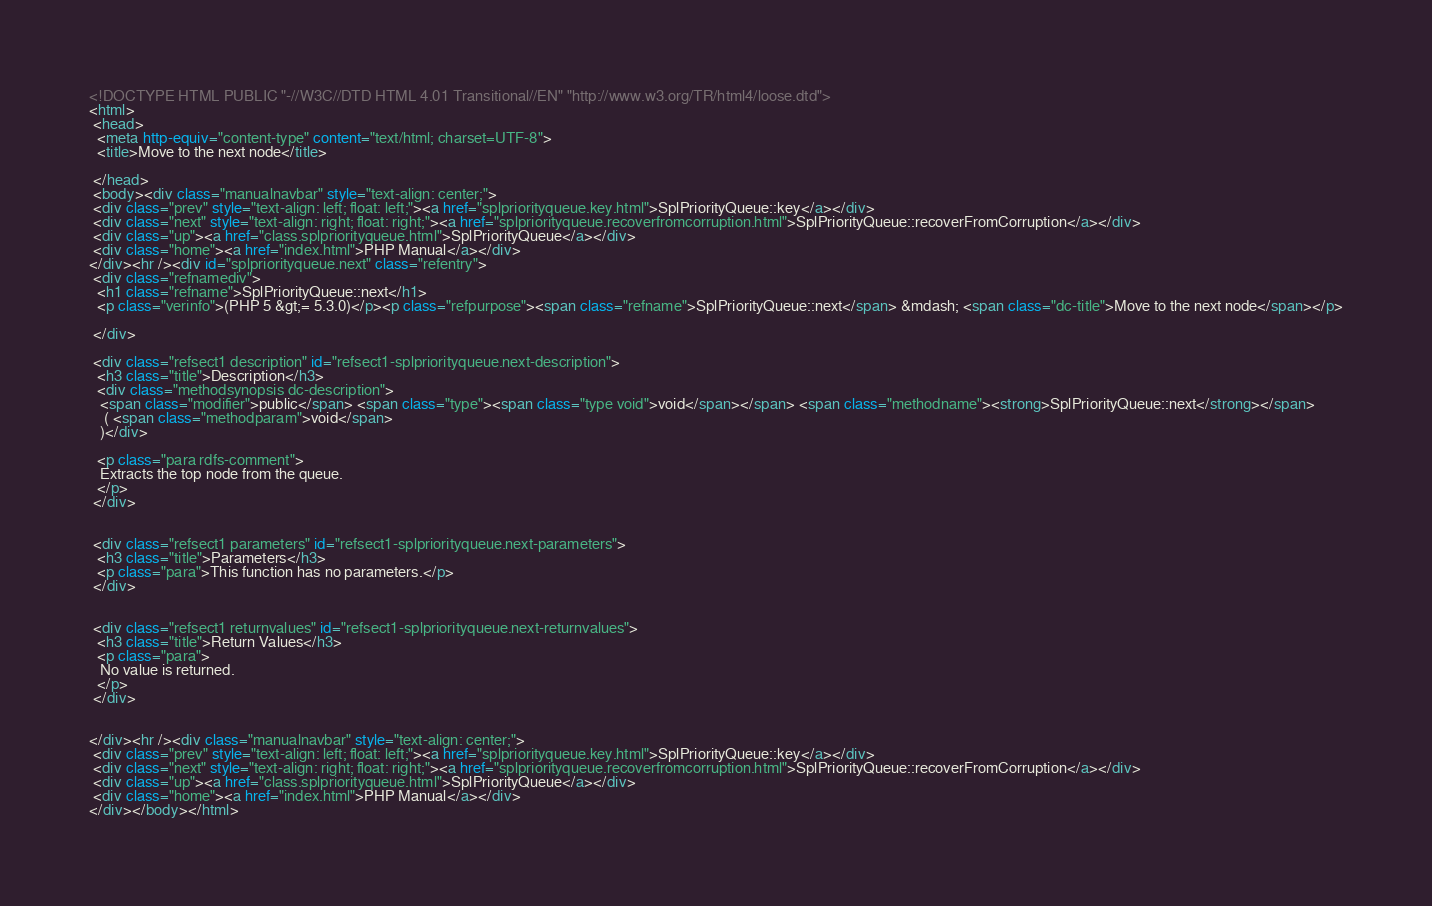<code> <loc_0><loc_0><loc_500><loc_500><_HTML_><!DOCTYPE HTML PUBLIC "-//W3C//DTD HTML 4.01 Transitional//EN" "http://www.w3.org/TR/html4/loose.dtd">
<html>
 <head>
  <meta http-equiv="content-type" content="text/html; charset=UTF-8">
  <title>Move to the next node</title>

 </head>
 <body><div class="manualnavbar" style="text-align: center;">
 <div class="prev" style="text-align: left; float: left;"><a href="splpriorityqueue.key.html">SplPriorityQueue::key</a></div>
 <div class="next" style="text-align: right; float: right;"><a href="splpriorityqueue.recoverfromcorruption.html">SplPriorityQueue::recoverFromCorruption</a></div>
 <div class="up"><a href="class.splpriorityqueue.html">SplPriorityQueue</a></div>
 <div class="home"><a href="index.html">PHP Manual</a></div>
</div><hr /><div id="splpriorityqueue.next" class="refentry">
 <div class="refnamediv">
  <h1 class="refname">SplPriorityQueue::next</h1>
  <p class="verinfo">(PHP 5 &gt;= 5.3.0)</p><p class="refpurpose"><span class="refname">SplPriorityQueue::next</span> &mdash; <span class="dc-title">Move to the next node</span></p>

 </div>

 <div class="refsect1 description" id="refsect1-splpriorityqueue.next-description">
  <h3 class="title">Description</h3>
  <div class="methodsynopsis dc-description">
   <span class="modifier">public</span> <span class="type"><span class="type void">void</span></span> <span class="methodname"><strong>SplPriorityQueue::next</strong></span>
    ( <span class="methodparam">void</span>
   )</div>

  <p class="para rdfs-comment">
   Extracts the top node from the queue.
  </p>
 </div>


 <div class="refsect1 parameters" id="refsect1-splpriorityqueue.next-parameters">
  <h3 class="title">Parameters</h3>
  <p class="para">This function has no parameters.</p>
 </div>


 <div class="refsect1 returnvalues" id="refsect1-splpriorityqueue.next-returnvalues">
  <h3 class="title">Return Values</h3>
  <p class="para">
   No value is returned.
  </p>
 </div>


</div><hr /><div class="manualnavbar" style="text-align: center;">
 <div class="prev" style="text-align: left; float: left;"><a href="splpriorityqueue.key.html">SplPriorityQueue::key</a></div>
 <div class="next" style="text-align: right; float: right;"><a href="splpriorityqueue.recoverfromcorruption.html">SplPriorityQueue::recoverFromCorruption</a></div>
 <div class="up"><a href="class.splpriorityqueue.html">SplPriorityQueue</a></div>
 <div class="home"><a href="index.html">PHP Manual</a></div>
</div></body></html>
</code> 